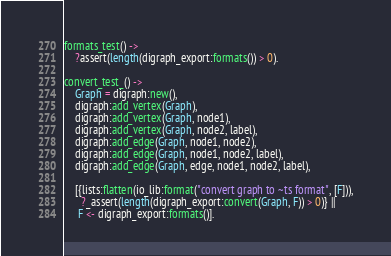<code> <loc_0><loc_0><loc_500><loc_500><_Erlang_>formats_test() ->
    ?assert(length(digraph_export:formats()) > 0).

convert_test_() ->
    Graph = digraph:new(),
    digraph:add_vertex(Graph),
    digraph:add_vertex(Graph, node1),
    digraph:add_vertex(Graph, node2, label),
    digraph:add_edge(Graph, node1, node2),
    digraph:add_edge(Graph, node1, node2, label),
    digraph:add_edge(Graph, edge, node1, node2, label),

    [{lists:flatten(io_lib:format("convert graph to ~ts format", [F])),
      ?_assert(length(digraph_export:convert(Graph, F)) > 0)} ||
     F <- digraph_export:formats()].
</code> 